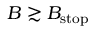Convert formula to latex. <formula><loc_0><loc_0><loc_500><loc_500>B \gtrsim B _ { s t o p }</formula> 